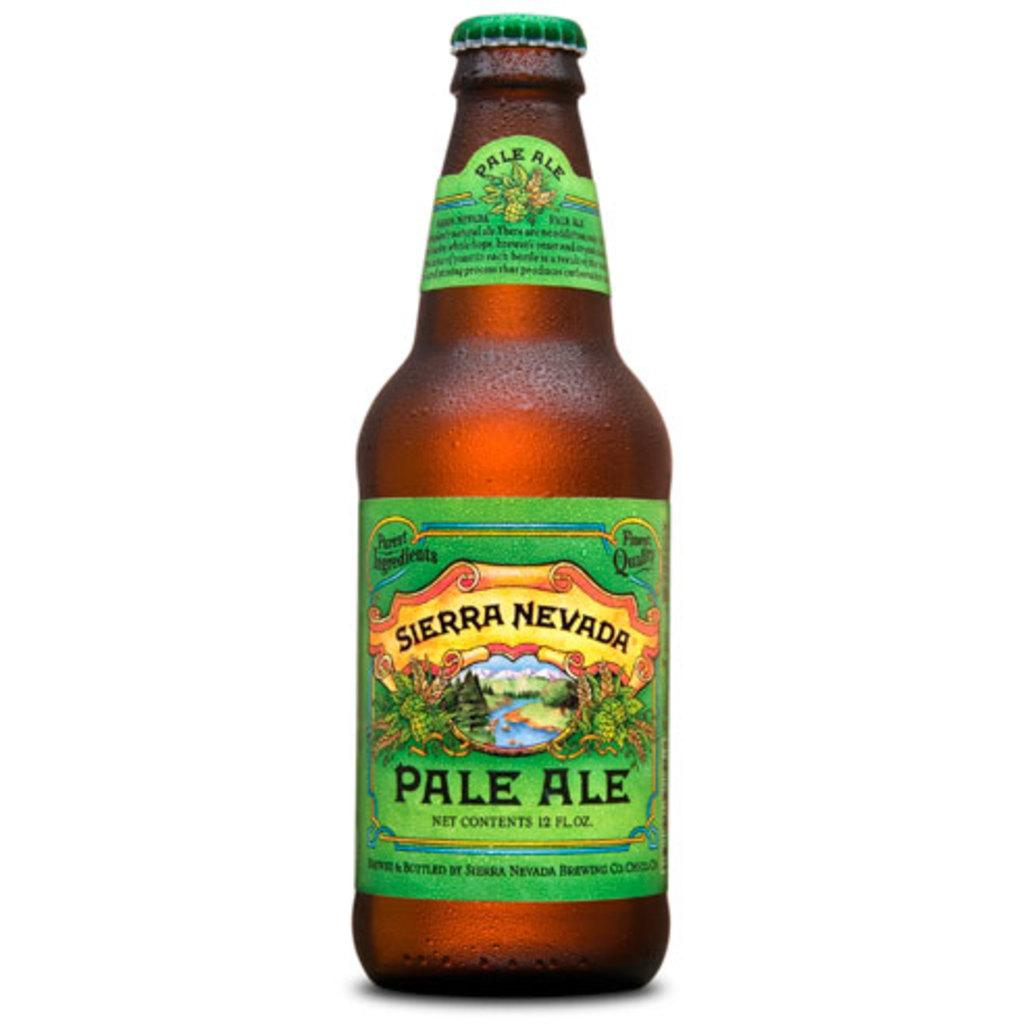<image>
Provide a brief description of the given image. a bottle of sierra nevada pale ale has a green label 